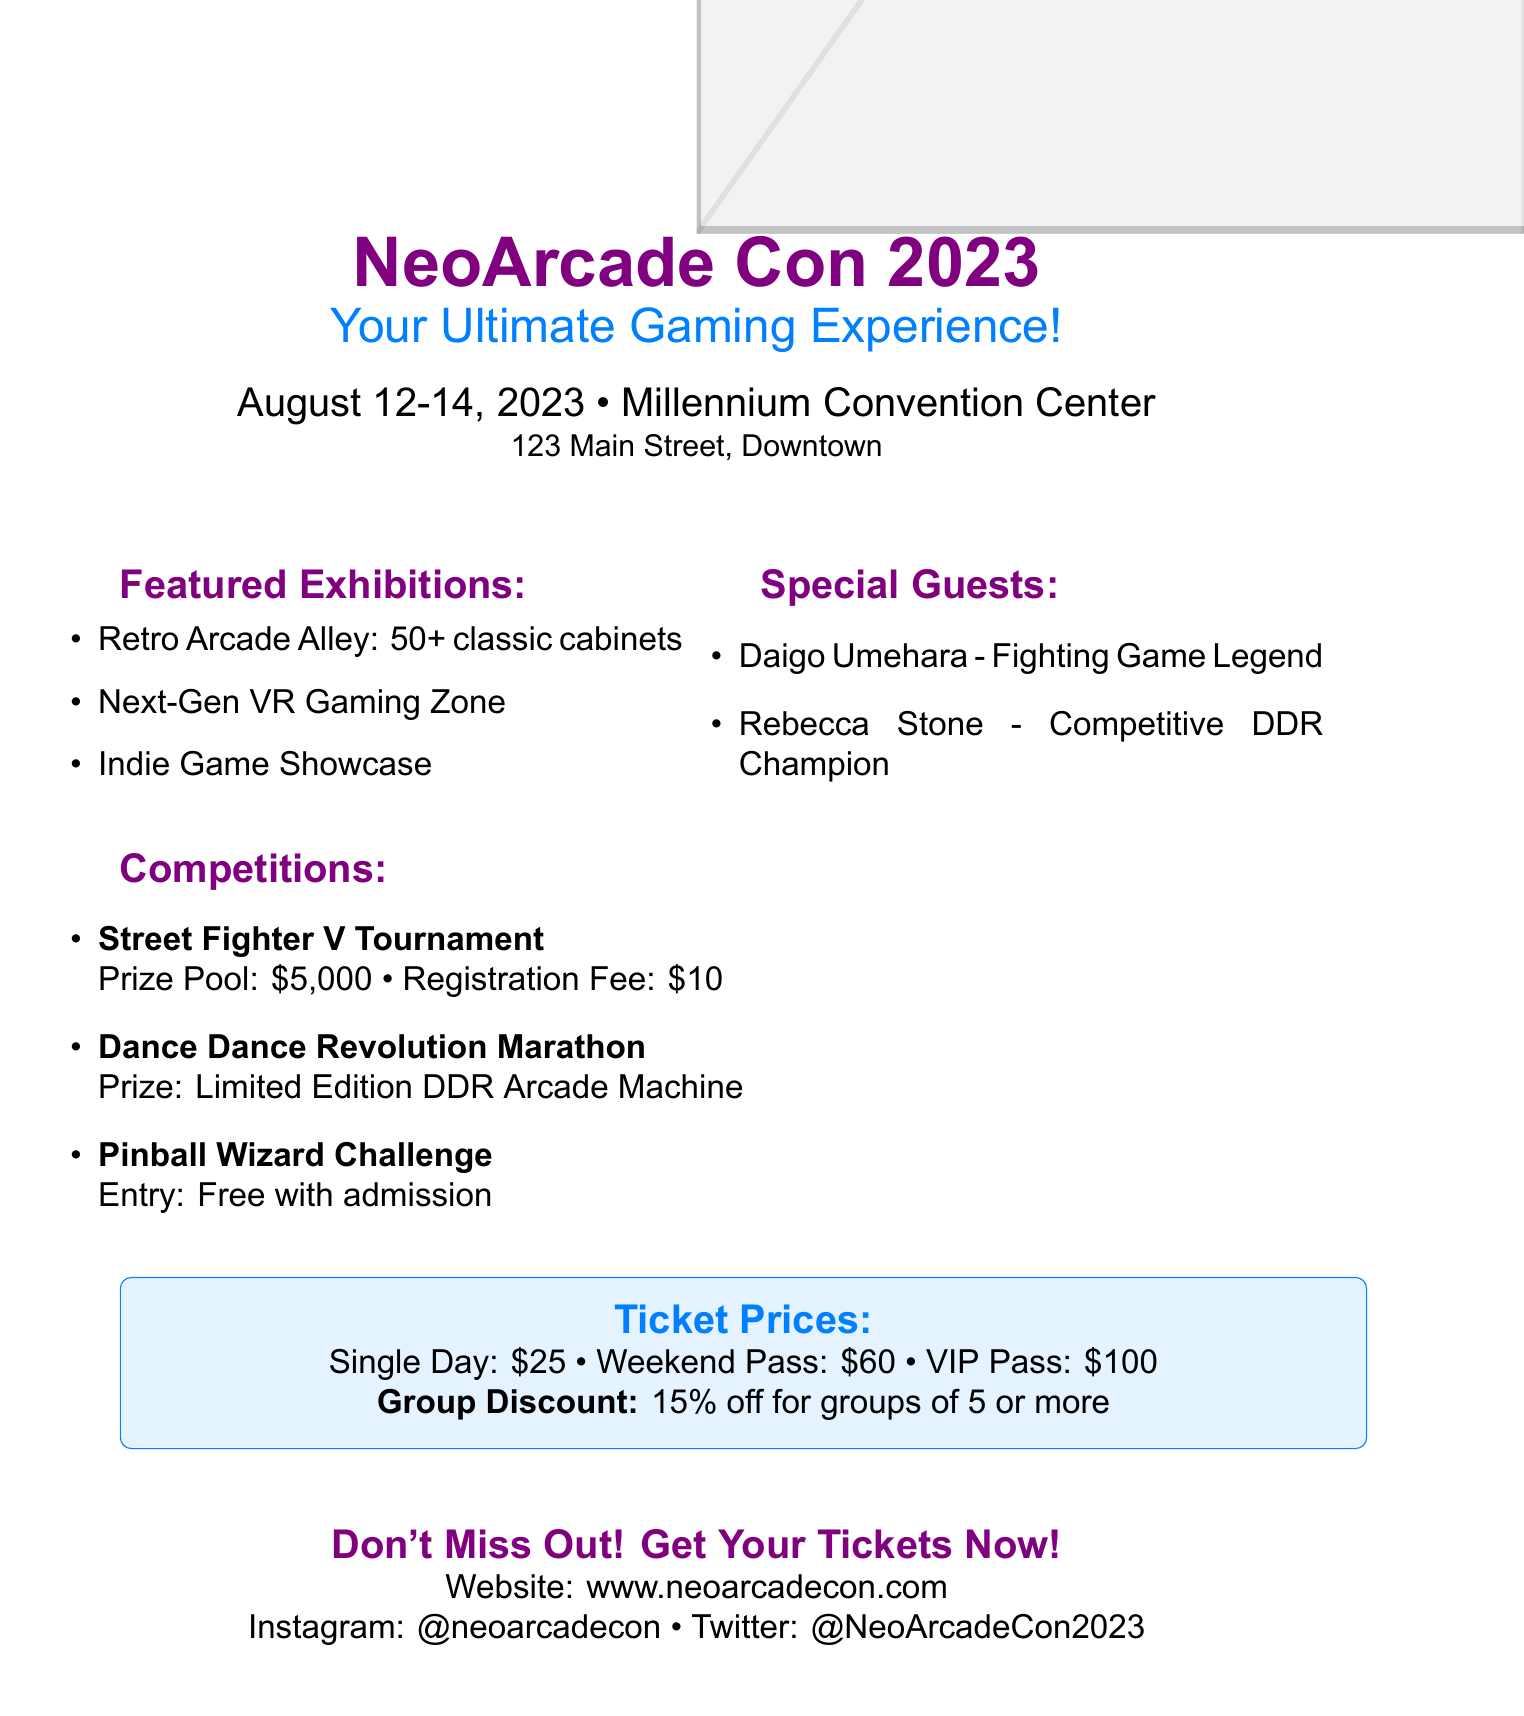What are the dates of NeoArcade Con 2023? The dates for NeoArcade Con 2023 are explicitly stated, which is August 12-14, 2023.
Answer: August 12-14, 2023 Where will the convention be held? The venue mentioned in the document is the Millennium Convention Center.
Answer: Millennium Convention Center What is the prize pool for the Street Fighter V Tournament? The prize pool for this competition is clearly stated as $5,000.
Answer: $5,000 What is the registration fee for the Street Fighter V Tournament? The registration fee is specified in the document as $10.
Answer: $10 Who is a special guest at the convention? The document highlights Daigo Umehara as one of the special guests.
Answer: Daigo Umehara What is the group discount percentage? The document mentions a group discount of 15% off for groups of 5 or more.
Answer: 15% What type of arcade cabinets can attendees expect to see? The featured exhibitions include "Retro Arcade Alley" with 50+ classic cabinets.
Answer: 50+ classic cabinets What is the entry fee for the Pinball Wizard Challenge? It is stated that entry to this challenge is free with admission.
Answer: Free with admission What social media platforms are mentioned for the convention? The document specifies Instagram and Twitter as the listed platforms.
Answer: Instagram and Twitter 